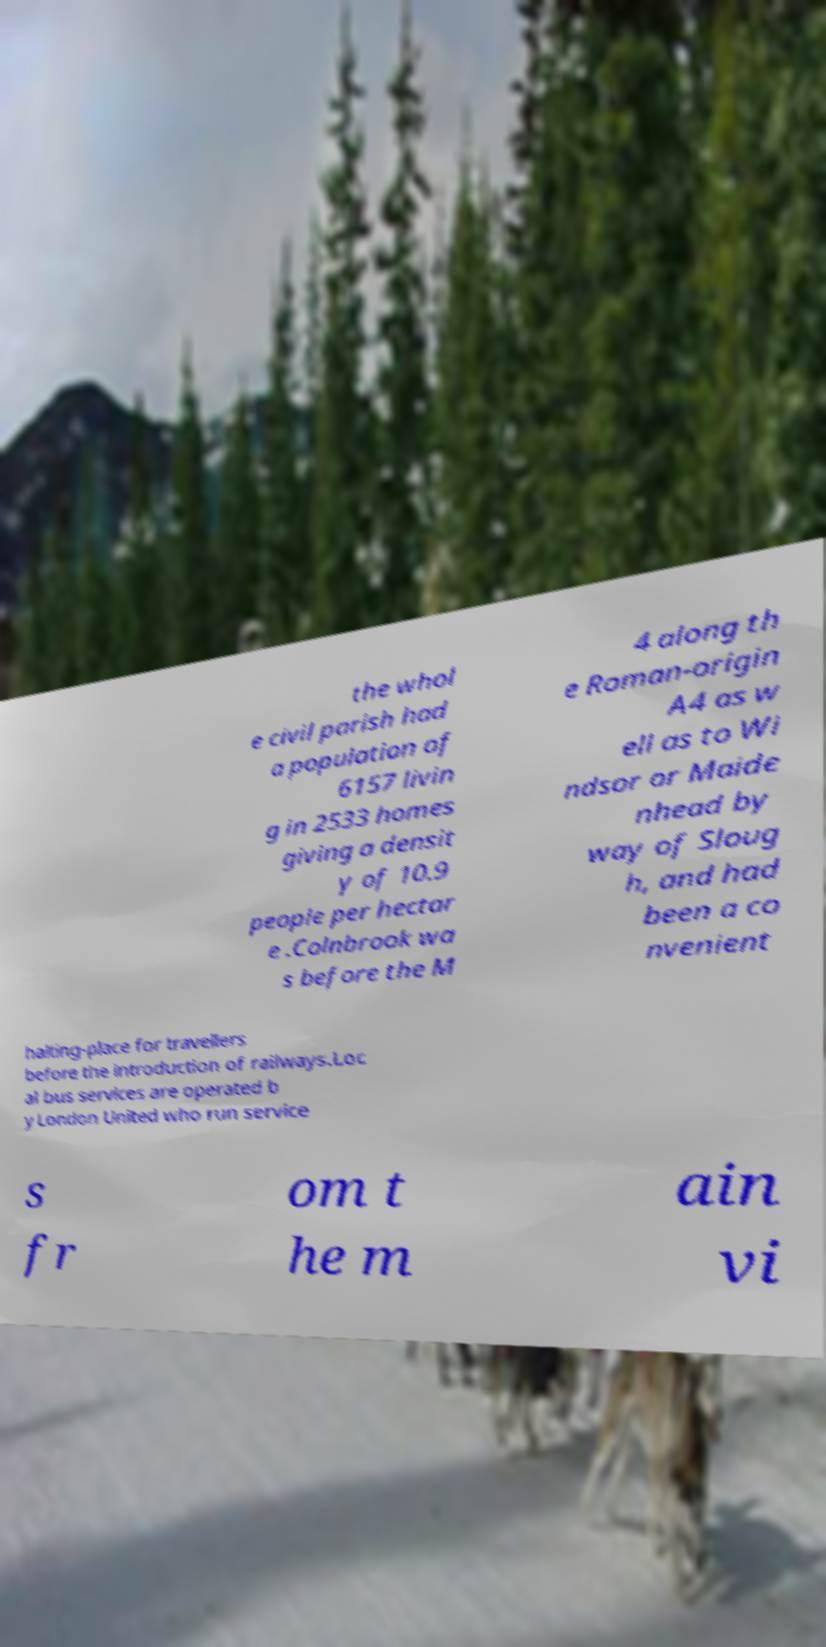For documentation purposes, I need the text within this image transcribed. Could you provide that? the whol e civil parish had a population of 6157 livin g in 2533 homes giving a densit y of 10.9 people per hectar e .Colnbrook wa s before the M 4 along th e Roman-origin A4 as w ell as to Wi ndsor or Maide nhead by way of Sloug h, and had been a co nvenient halting-place for travellers before the introduction of railways.Loc al bus services are operated b y London United who run service s fr om t he m ain vi 